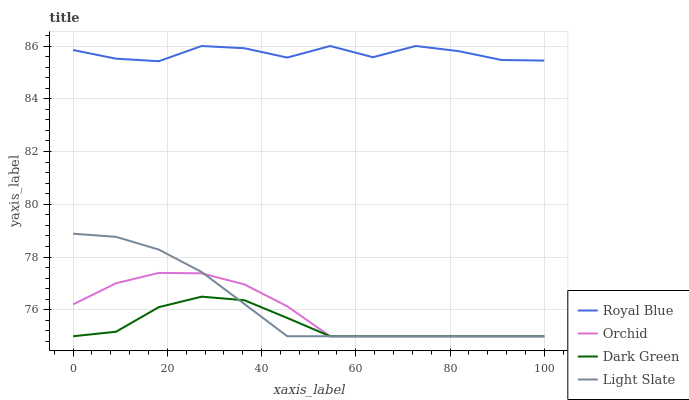Does Dark Green have the minimum area under the curve?
Answer yes or no. Yes. Does Royal Blue have the maximum area under the curve?
Answer yes or no. Yes. Does Royal Blue have the minimum area under the curve?
Answer yes or no. No. Does Dark Green have the maximum area under the curve?
Answer yes or no. No. Is Light Slate the smoothest?
Answer yes or no. Yes. Is Royal Blue the roughest?
Answer yes or no. Yes. Is Dark Green the smoothest?
Answer yes or no. No. Is Dark Green the roughest?
Answer yes or no. No. Does Light Slate have the lowest value?
Answer yes or no. Yes. Does Royal Blue have the lowest value?
Answer yes or no. No. Does Royal Blue have the highest value?
Answer yes or no. Yes. Does Dark Green have the highest value?
Answer yes or no. No. Is Light Slate less than Royal Blue?
Answer yes or no. Yes. Is Royal Blue greater than Orchid?
Answer yes or no. Yes. Does Dark Green intersect Orchid?
Answer yes or no. Yes. Is Dark Green less than Orchid?
Answer yes or no. No. Is Dark Green greater than Orchid?
Answer yes or no. No. Does Light Slate intersect Royal Blue?
Answer yes or no. No. 